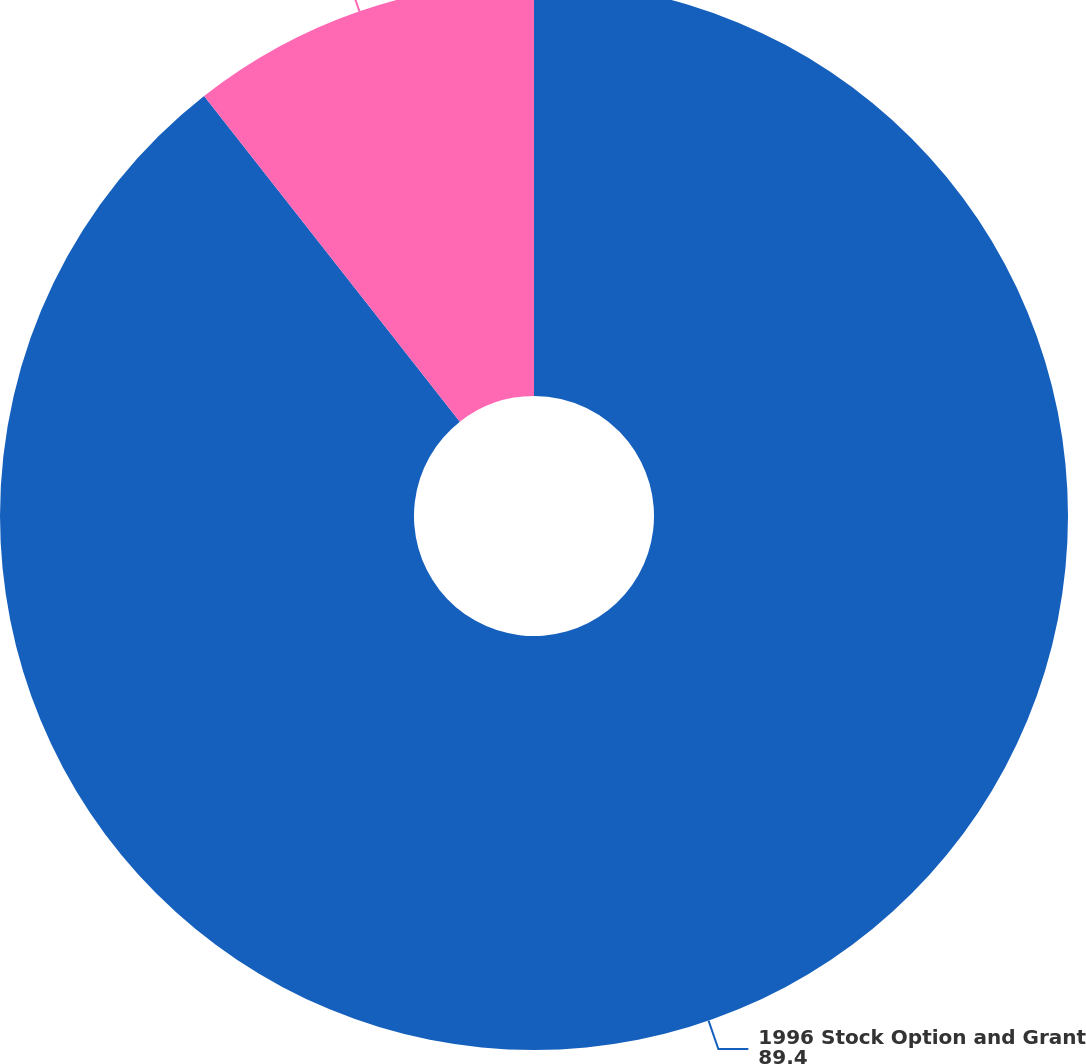Convert chart to OTSL. <chart><loc_0><loc_0><loc_500><loc_500><pie_chart><fcel>1996 Stock Option and Grant<fcel>1996 Employee Stock Purchase<nl><fcel>89.4%<fcel>10.6%<nl></chart> 